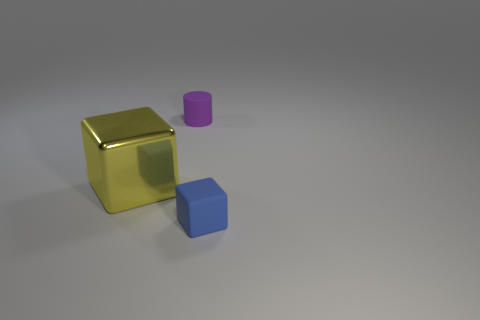Is there anything else that is the same size as the yellow metal cube?
Your answer should be compact. No. How big is the object that is behind the small blue cube and in front of the small purple cylinder?
Make the answer very short. Large. What number of other things are there of the same color as the big thing?
Offer a very short reply. 0. How big is the object on the left side of the small rubber thing to the left of the tiny rubber object that is in front of the large yellow block?
Make the answer very short. Large. There is a yellow thing; are there any small blue matte things right of it?
Ensure brevity in your answer.  Yes. There is a shiny block; does it have the same size as the rubber thing that is in front of the cylinder?
Your answer should be compact. No. What number of other things are there of the same material as the tiny block
Provide a succinct answer. 1. There is a object that is both to the left of the tiny block and on the right side of the big cube; what is its shape?
Make the answer very short. Cylinder. There is a yellow cube that is behind the tiny blue matte object; does it have the same size as the rubber thing in front of the purple rubber cylinder?
Offer a very short reply. No. What shape is the other object that is made of the same material as the blue thing?
Give a very brief answer. Cylinder. 